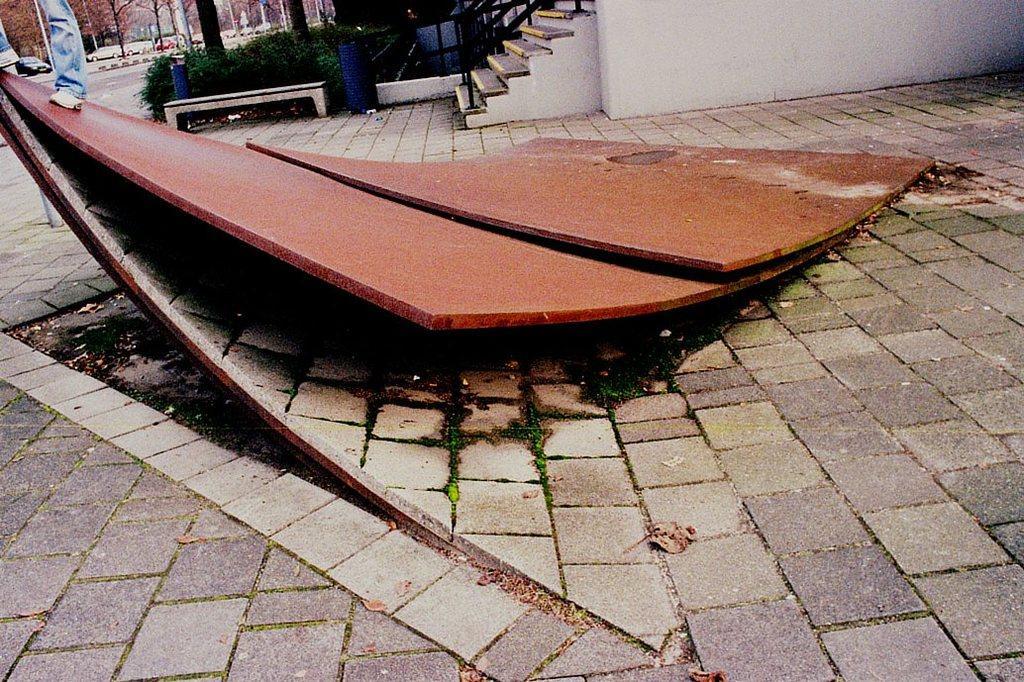How would you summarize this image in a sentence or two? This image is clicked outside. In the front, we can see two metal sheets. At the bottom, there is ground. On the left, there is a man standing on a metal sheet. In the background, we can see the cars parked on the road. And there are many trees. 